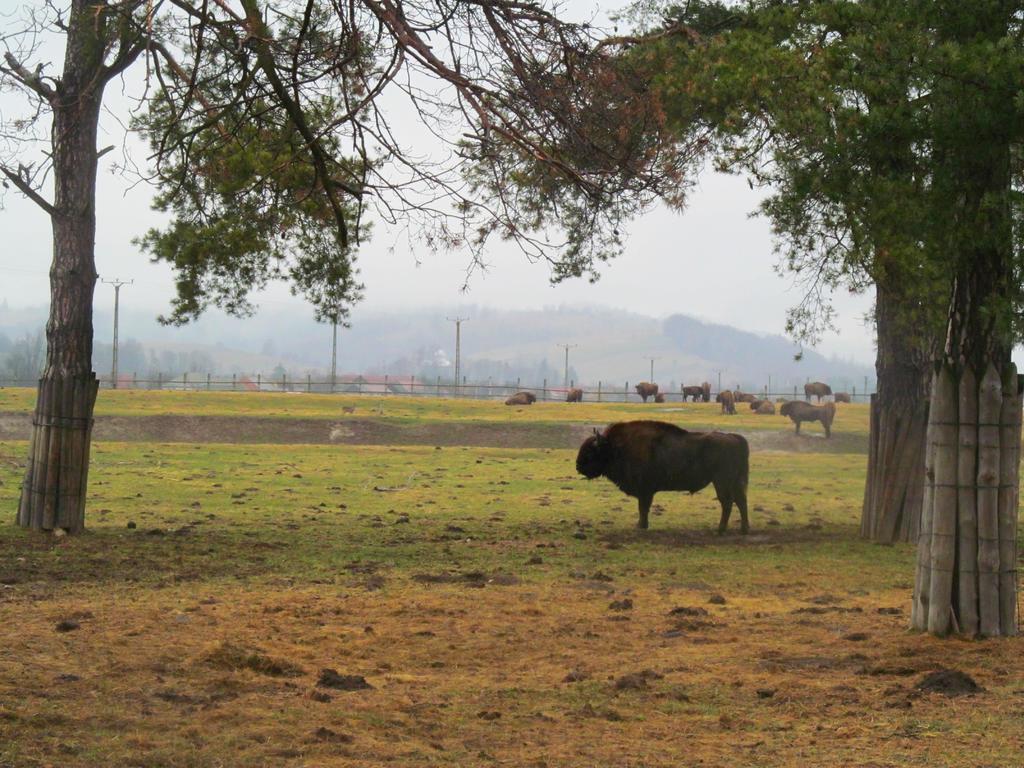In one or two sentences, can you explain what this image depicts? This is the picture of a place where we have some trees, plants, grass on the floor and also we can see some oxen and some mountains around. 